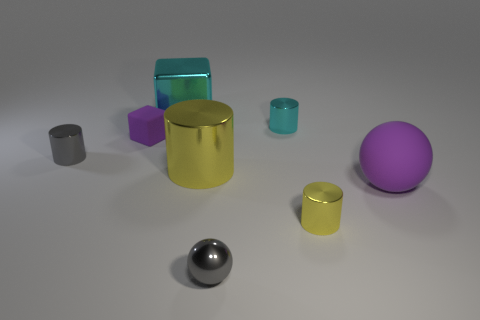The rubber thing that is the same color as the matte sphere is what shape? The object you're referring to appears to be a cube. It shares the same color as the matte sphere, which is a shade of purple. 